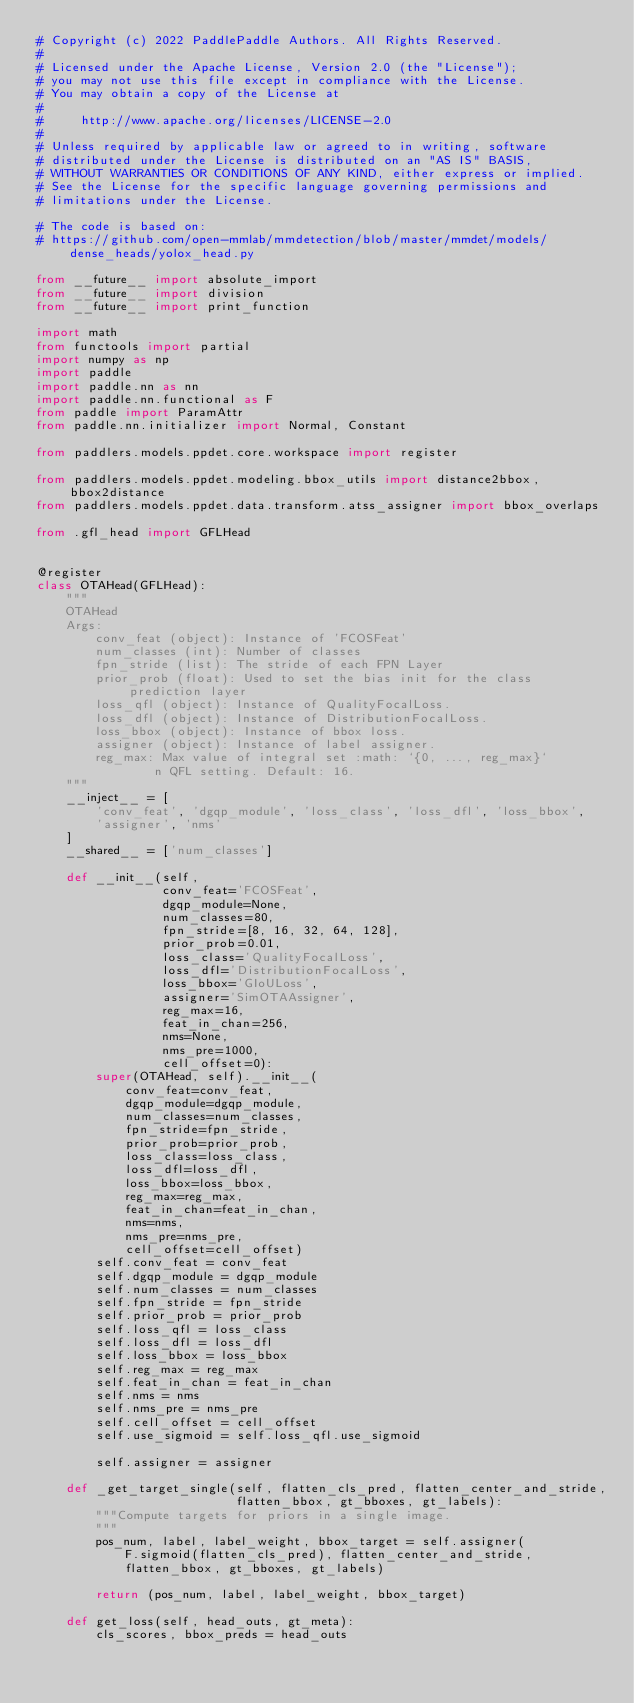<code> <loc_0><loc_0><loc_500><loc_500><_Python_># Copyright (c) 2022 PaddlePaddle Authors. All Rights Reserved.
#
# Licensed under the Apache License, Version 2.0 (the "License");
# you may not use this file except in compliance with the License.
# You may obtain a copy of the License at
#
#     http://www.apache.org/licenses/LICENSE-2.0
#
# Unless required by applicable law or agreed to in writing, software
# distributed under the License is distributed on an "AS IS" BASIS,
# WITHOUT WARRANTIES OR CONDITIONS OF ANY KIND, either express or implied.
# See the License for the specific language governing permissions and
# limitations under the License.

# The code is based on:
# https://github.com/open-mmlab/mmdetection/blob/master/mmdet/models/dense_heads/yolox_head.py

from __future__ import absolute_import
from __future__ import division
from __future__ import print_function

import math
from functools import partial
import numpy as np
import paddle
import paddle.nn as nn
import paddle.nn.functional as F
from paddle import ParamAttr
from paddle.nn.initializer import Normal, Constant

from paddlers.models.ppdet.core.workspace import register

from paddlers.models.ppdet.modeling.bbox_utils import distance2bbox, bbox2distance
from paddlers.models.ppdet.data.transform.atss_assigner import bbox_overlaps

from .gfl_head import GFLHead


@register
class OTAHead(GFLHead):
    """
    OTAHead
    Args:
        conv_feat (object): Instance of 'FCOSFeat'
        num_classes (int): Number of classes
        fpn_stride (list): The stride of each FPN Layer
        prior_prob (float): Used to set the bias init for the class prediction layer
        loss_qfl (object): Instance of QualityFocalLoss.
        loss_dfl (object): Instance of DistributionFocalLoss.
        loss_bbox (object): Instance of bbox loss.
        assigner (object): Instance of label assigner.
        reg_max: Max value of integral set :math: `{0, ..., reg_max}`
                n QFL setting. Default: 16.
    """
    __inject__ = [
        'conv_feat', 'dgqp_module', 'loss_class', 'loss_dfl', 'loss_bbox',
        'assigner', 'nms'
    ]
    __shared__ = ['num_classes']

    def __init__(self,
                 conv_feat='FCOSFeat',
                 dgqp_module=None,
                 num_classes=80,
                 fpn_stride=[8, 16, 32, 64, 128],
                 prior_prob=0.01,
                 loss_class='QualityFocalLoss',
                 loss_dfl='DistributionFocalLoss',
                 loss_bbox='GIoULoss',
                 assigner='SimOTAAssigner',
                 reg_max=16,
                 feat_in_chan=256,
                 nms=None,
                 nms_pre=1000,
                 cell_offset=0):
        super(OTAHead, self).__init__(
            conv_feat=conv_feat,
            dgqp_module=dgqp_module,
            num_classes=num_classes,
            fpn_stride=fpn_stride,
            prior_prob=prior_prob,
            loss_class=loss_class,
            loss_dfl=loss_dfl,
            loss_bbox=loss_bbox,
            reg_max=reg_max,
            feat_in_chan=feat_in_chan,
            nms=nms,
            nms_pre=nms_pre,
            cell_offset=cell_offset)
        self.conv_feat = conv_feat
        self.dgqp_module = dgqp_module
        self.num_classes = num_classes
        self.fpn_stride = fpn_stride
        self.prior_prob = prior_prob
        self.loss_qfl = loss_class
        self.loss_dfl = loss_dfl
        self.loss_bbox = loss_bbox
        self.reg_max = reg_max
        self.feat_in_chan = feat_in_chan
        self.nms = nms
        self.nms_pre = nms_pre
        self.cell_offset = cell_offset
        self.use_sigmoid = self.loss_qfl.use_sigmoid

        self.assigner = assigner

    def _get_target_single(self, flatten_cls_pred, flatten_center_and_stride,
                           flatten_bbox, gt_bboxes, gt_labels):
        """Compute targets for priors in a single image.
        """
        pos_num, label, label_weight, bbox_target = self.assigner(
            F.sigmoid(flatten_cls_pred), flatten_center_and_stride,
            flatten_bbox, gt_bboxes, gt_labels)

        return (pos_num, label, label_weight, bbox_target)

    def get_loss(self, head_outs, gt_meta):
        cls_scores, bbox_preds = head_outs</code> 